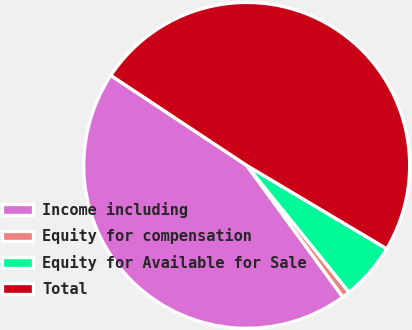Convert chart to OTSL. <chart><loc_0><loc_0><loc_500><loc_500><pie_chart><fcel>Income including<fcel>Equity for compensation<fcel>Equity for Available for Sale<fcel>Total<nl><fcel>44.35%<fcel>0.76%<fcel>5.65%<fcel>49.24%<nl></chart> 